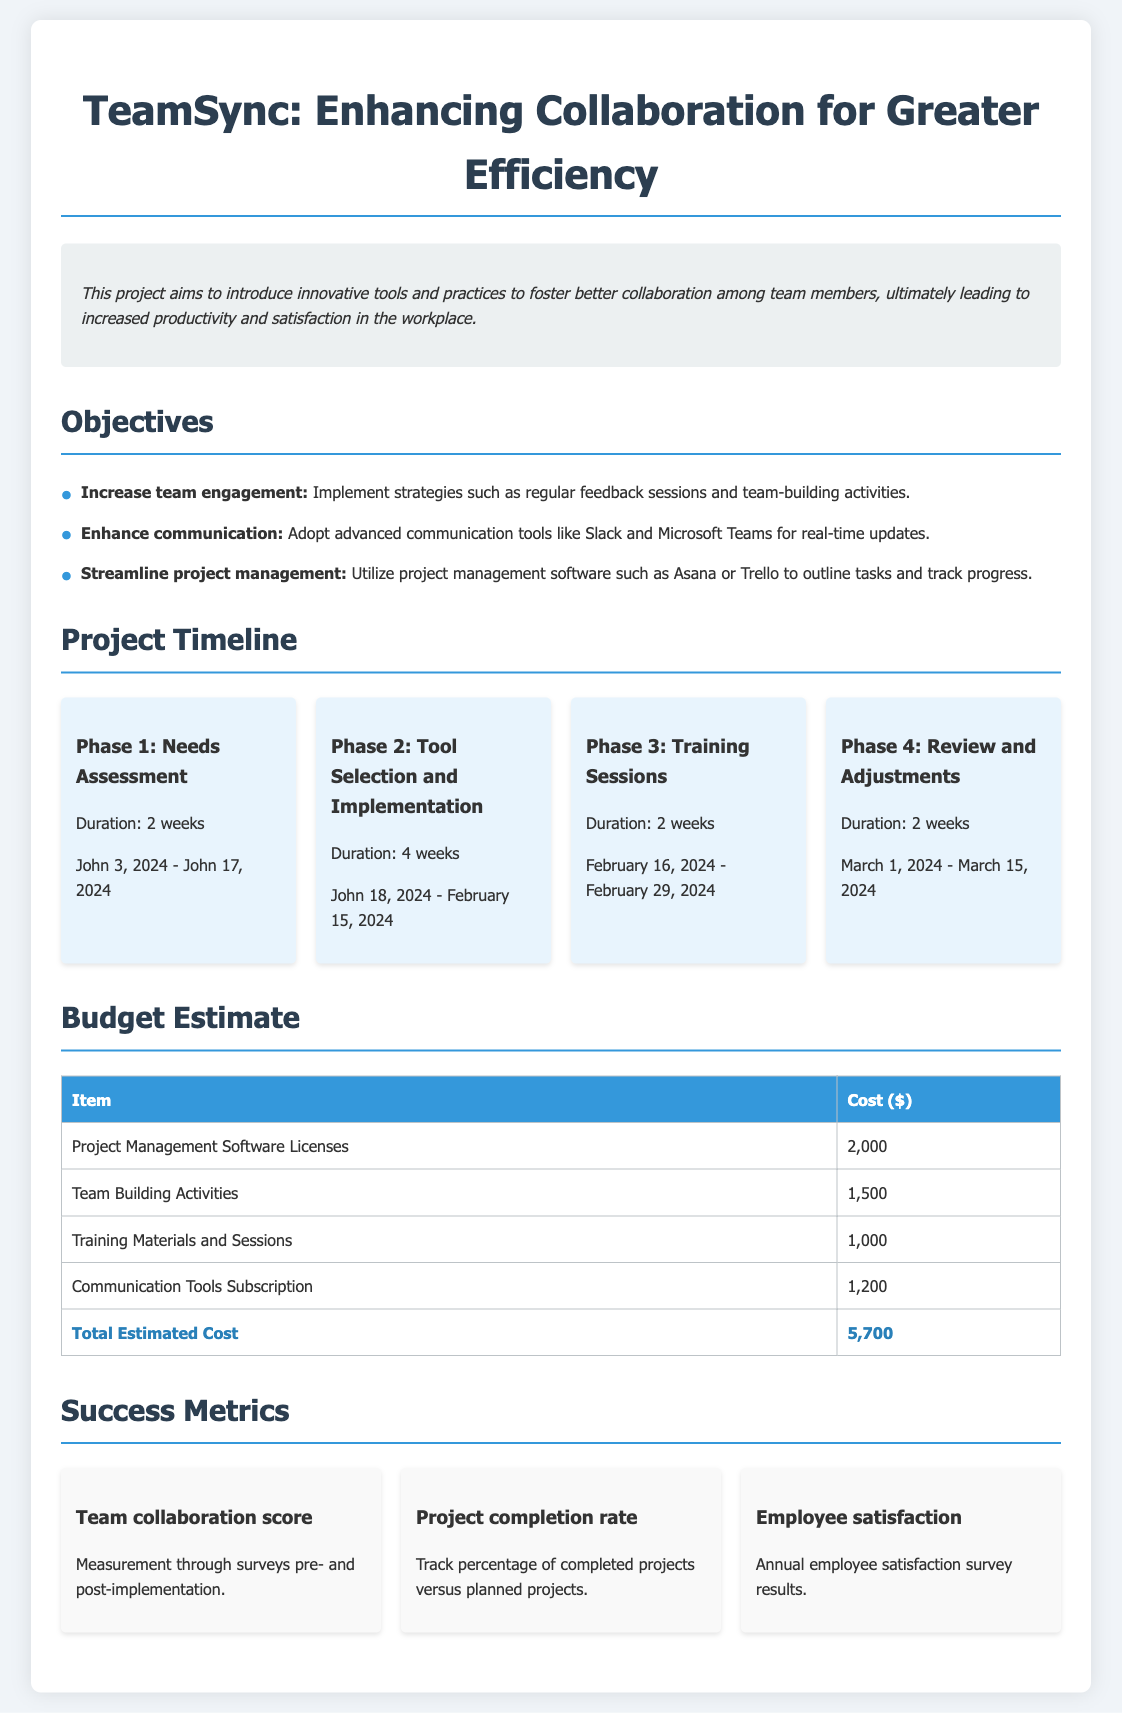What is the title of the project? The title of the project is mentioned at the beginning of the document.
Answer: TeamSync: Enhancing Collaboration for Greater Efficiency What is the duration of Phase 2? The duration of Phase 2 is specified in the timeline section.
Answer: 4 weeks Who is responsible for Phase 1? The document lists the schedule but does not specify a responsible person in the timeline section.
Answer: Not specified What is the cost for Training Materials and Sessions? The budget section provides the cost breakdown for each item.
Answer: 1,000 What is the total estimated cost for the project? The total estimated cost is calculated from the individual budget items listed.
Answer: 5,700 What measurement is used for the team collaboration score? The document describes how the success metrics will be assessed, specifically mentioning surveys.
Answer: Surveys How many phases are outlined in the project timeline? The timeline section lists each phase separately to provide an overview.
Answer: 4 phases What tool is suggested for real-time updates? The objectives section identifies specific tools recommended for enhancement of communication.
Answer: Slack and Microsoft Teams What is the aim of the project? The document provides a summary in the overview section about what the project intends to achieve.
Answer: Improve team collaboration 